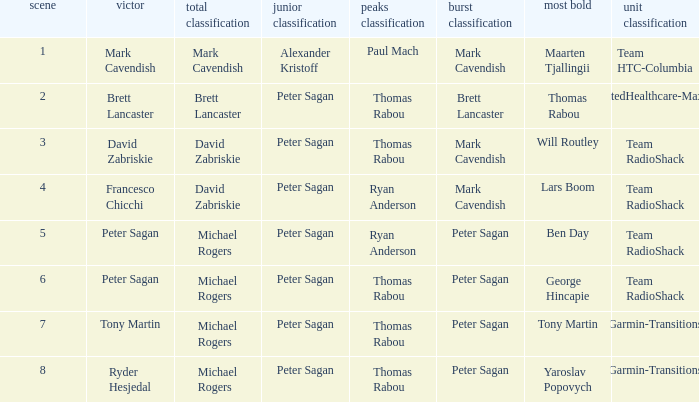Who won the mountains classification when Maarten Tjallingii won most corageous? Paul Mach. 